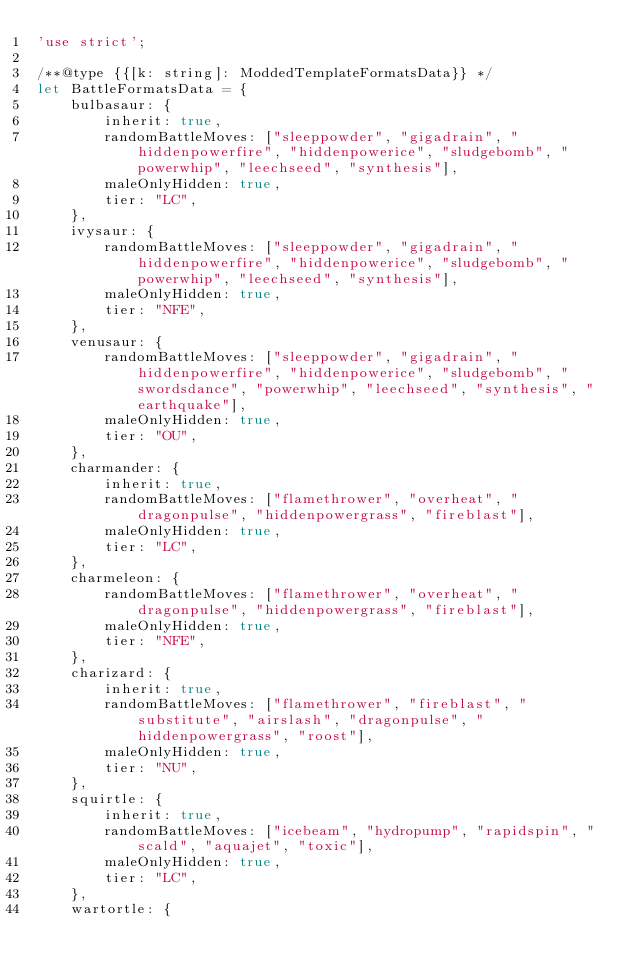<code> <loc_0><loc_0><loc_500><loc_500><_JavaScript_>'use strict';

/**@type {{[k: string]: ModdedTemplateFormatsData}} */
let BattleFormatsData = {
	bulbasaur: {
		inherit: true,
		randomBattleMoves: ["sleeppowder", "gigadrain", "hiddenpowerfire", "hiddenpowerice", "sludgebomb", "powerwhip", "leechseed", "synthesis"],
		maleOnlyHidden: true,
		tier: "LC",
	},
	ivysaur: {
		randomBattleMoves: ["sleeppowder", "gigadrain", "hiddenpowerfire", "hiddenpowerice", "sludgebomb", "powerwhip", "leechseed", "synthesis"],
		maleOnlyHidden: true,
		tier: "NFE",
	},
	venusaur: {
		randomBattleMoves: ["sleeppowder", "gigadrain", "hiddenpowerfire", "hiddenpowerice", "sludgebomb", "swordsdance", "powerwhip", "leechseed", "synthesis", "earthquake"],
		maleOnlyHidden: true,
		tier: "OU",
	},
	charmander: {
		inherit: true,
		randomBattleMoves: ["flamethrower", "overheat", "dragonpulse", "hiddenpowergrass", "fireblast"],
		maleOnlyHidden: true,
		tier: "LC",
	},
	charmeleon: {
		randomBattleMoves: ["flamethrower", "overheat", "dragonpulse", "hiddenpowergrass", "fireblast"],
		maleOnlyHidden: true,
		tier: "NFE",
	},
	charizard: {
		inherit: true,
		randomBattleMoves: ["flamethrower", "fireblast", "substitute", "airslash", "dragonpulse", "hiddenpowergrass", "roost"],
		maleOnlyHidden: true,
		tier: "NU",
	},
	squirtle: {
		inherit: true,
		randomBattleMoves: ["icebeam", "hydropump", "rapidspin", "scald", "aquajet", "toxic"],
		maleOnlyHidden: true,
		tier: "LC",
	},
	wartortle: {</code> 